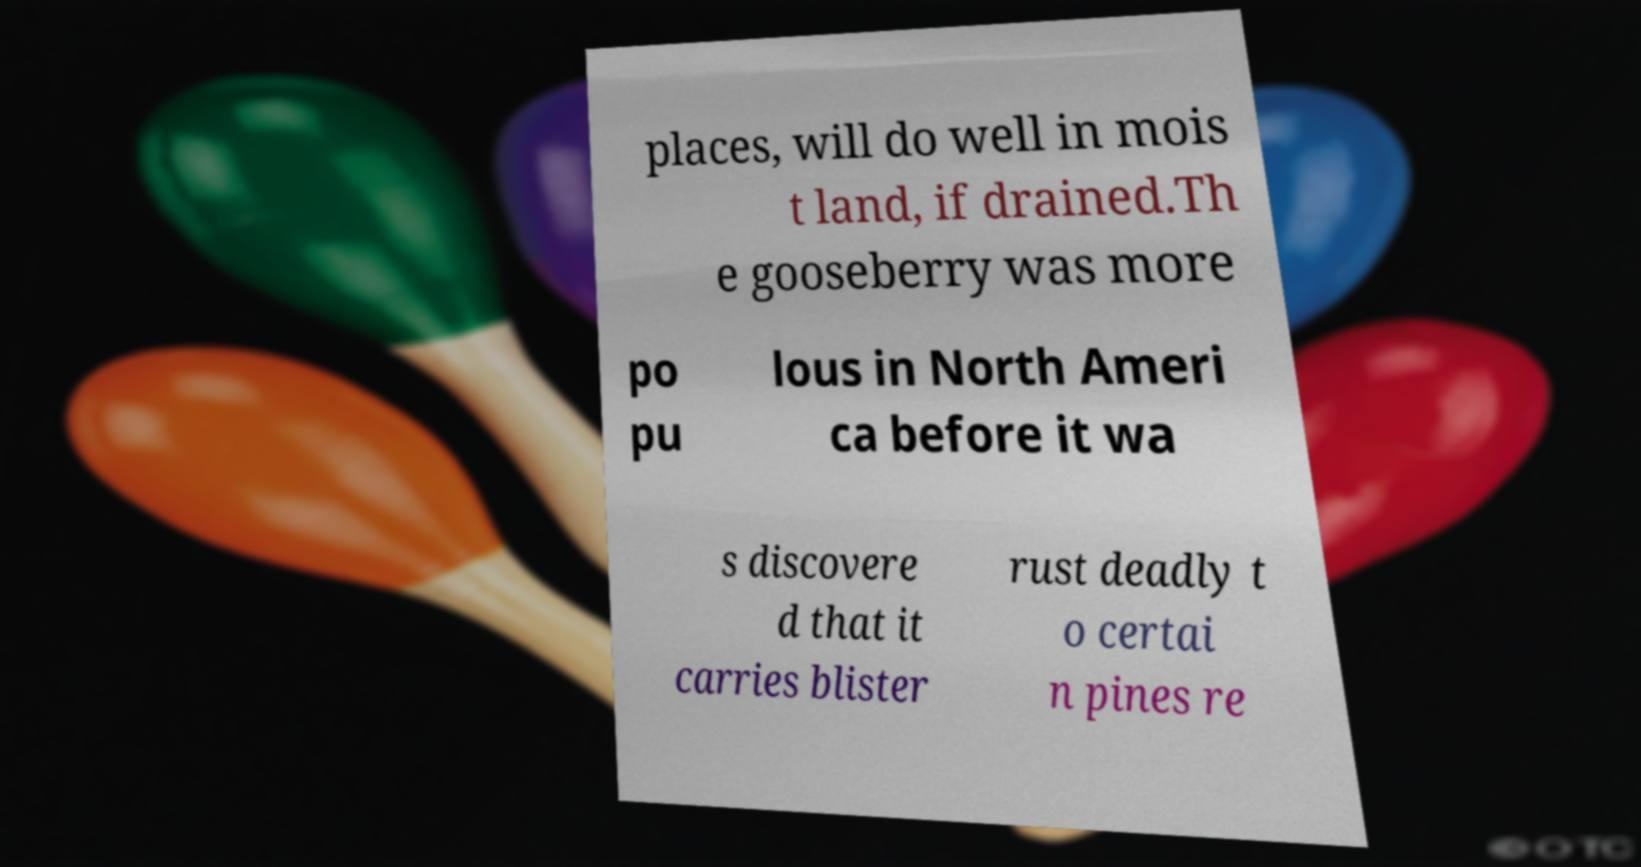Could you extract and type out the text from this image? places, will do well in mois t land, if drained.Th e gooseberry was more po pu lous in North Ameri ca before it wa s discovere d that it carries blister rust deadly t o certai n pines re 